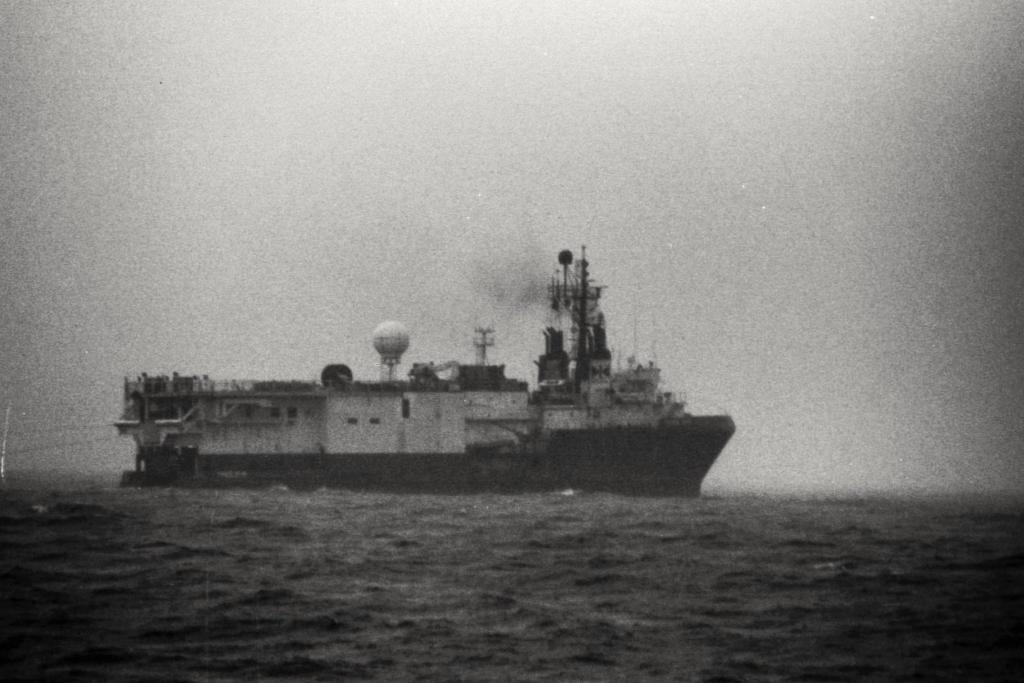What is the main subject of the image? The main subject of the image is water. What can be seen floating on the water? There is a boat in the image. What else is visible in the image besides the water and boat? The sky is visible in the image. How would you describe the overall lighting in the image? The image appears to be slightly dark. What letter is being used to answer questions about the image? There is no letter being used to answer questions about the image; the conversation is based on the provided facts. Is there an engine visible in the image? There is no engine present in the image; it only features water, a boat, and the sky. 